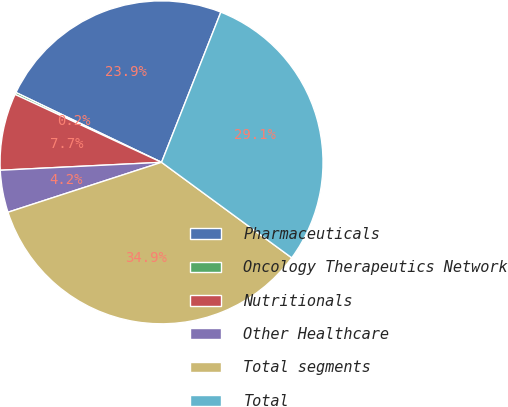Convert chart. <chart><loc_0><loc_0><loc_500><loc_500><pie_chart><fcel>Pharmaceuticals<fcel>Oncology Therapeutics Network<fcel>Nutritionals<fcel>Other Healthcare<fcel>Total segments<fcel>Total<nl><fcel>23.87%<fcel>0.21%<fcel>7.69%<fcel>4.22%<fcel>34.93%<fcel>29.09%<nl></chart> 